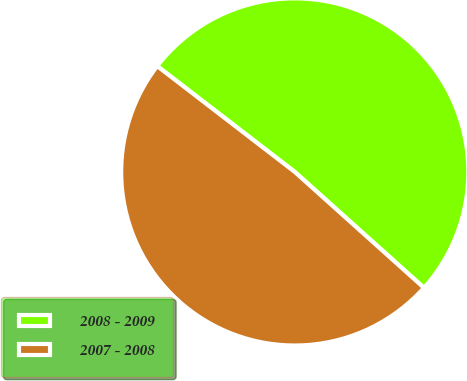<chart> <loc_0><loc_0><loc_500><loc_500><pie_chart><fcel>2008 - 2009<fcel>2007 - 2008<nl><fcel>51.2%<fcel>48.8%<nl></chart> 